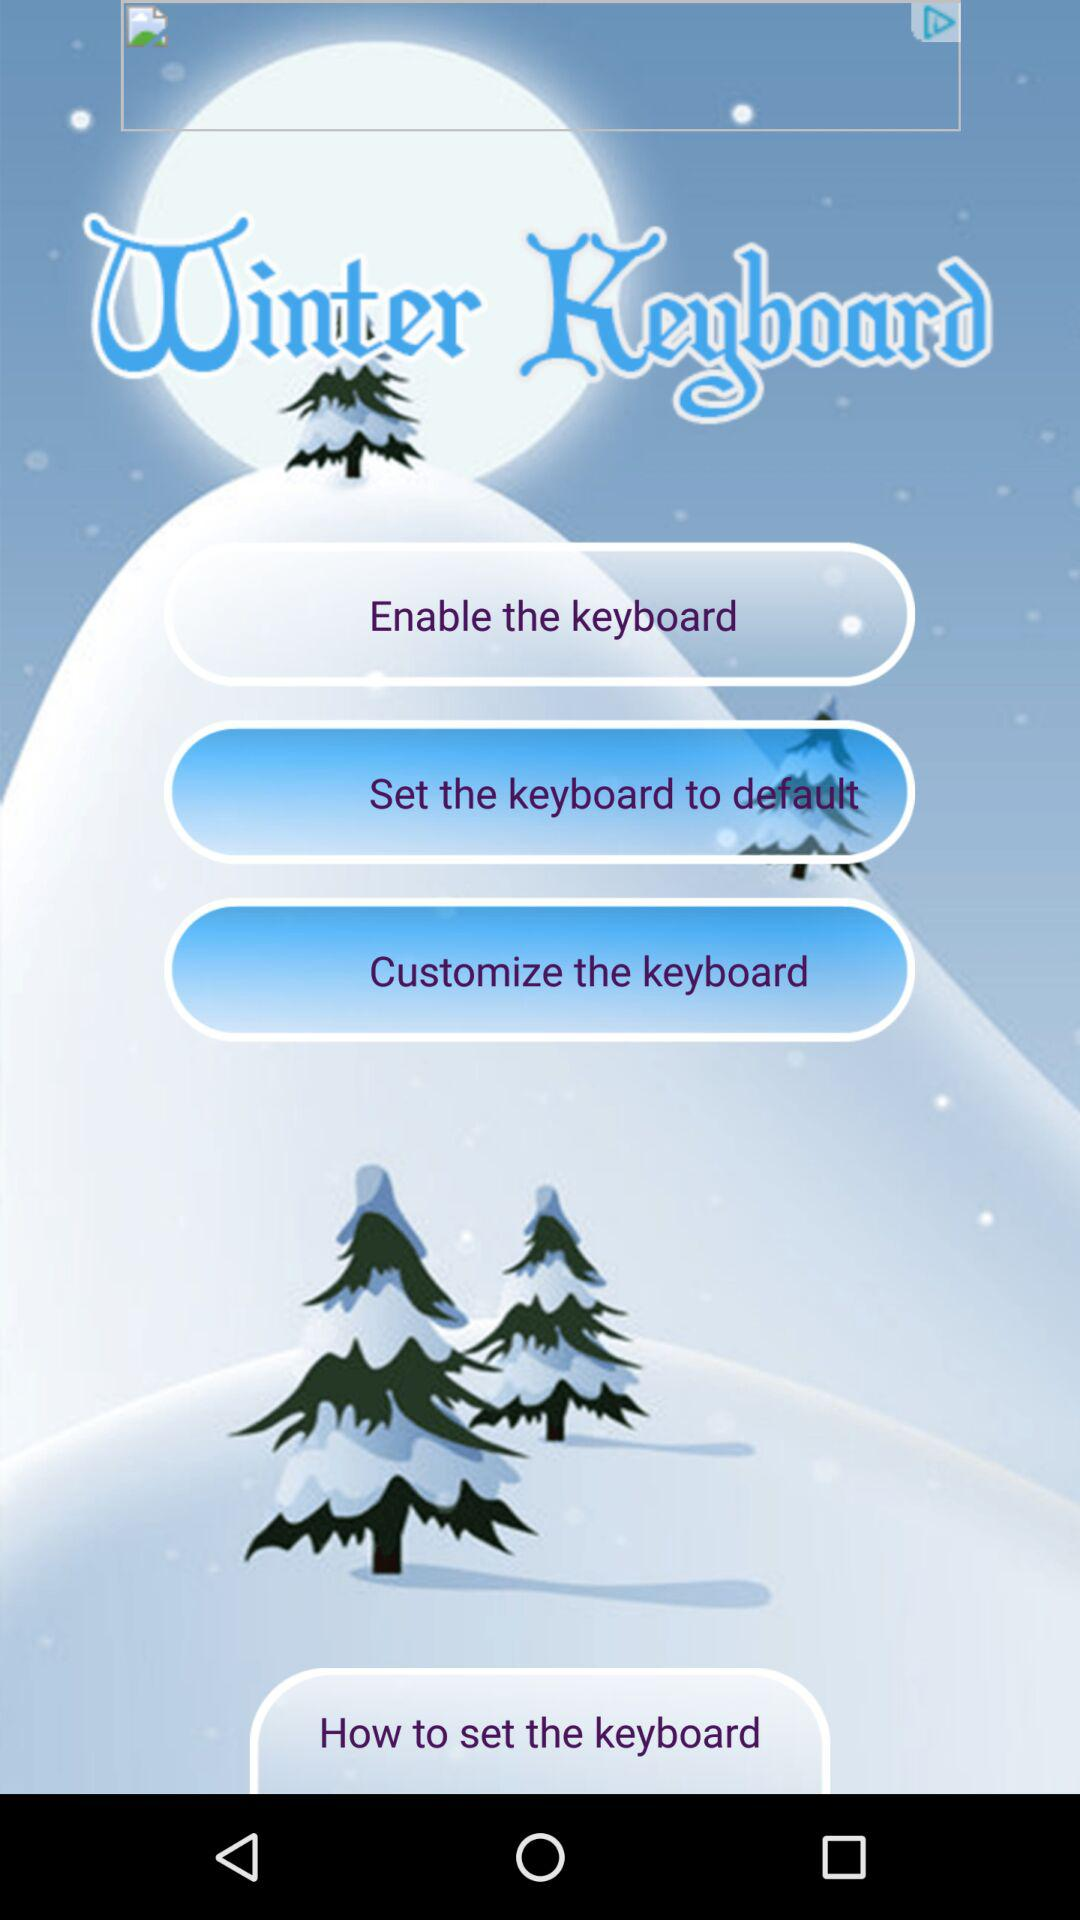What is the application name? The application name is "Winter Keyboard". 